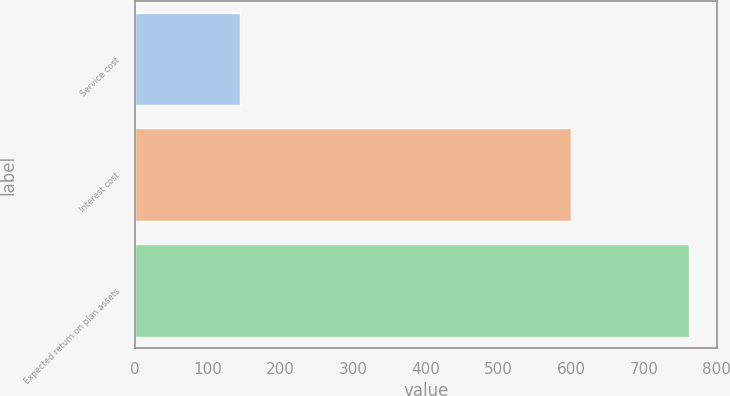Convert chart to OTSL. <chart><loc_0><loc_0><loc_500><loc_500><bar_chart><fcel>Service cost<fcel>Interest cost<fcel>Expected return on plan assets<nl><fcel>145<fcel>600<fcel>762<nl></chart> 